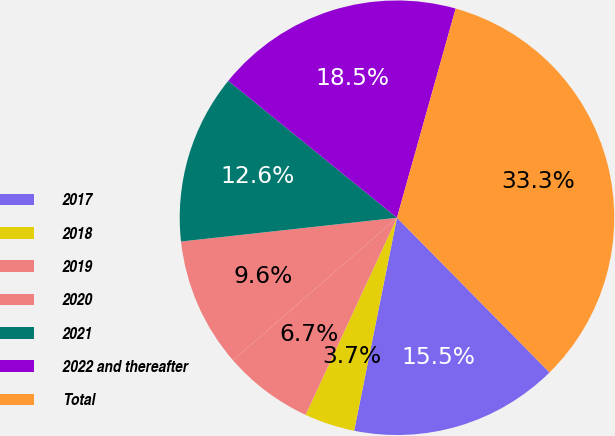Convert chart. <chart><loc_0><loc_0><loc_500><loc_500><pie_chart><fcel>2017<fcel>2018<fcel>2019<fcel>2020<fcel>2021<fcel>2022 and thereafter<fcel>Total<nl><fcel>15.55%<fcel>3.75%<fcel>6.7%<fcel>9.65%<fcel>12.6%<fcel>18.5%<fcel>33.26%<nl></chart> 